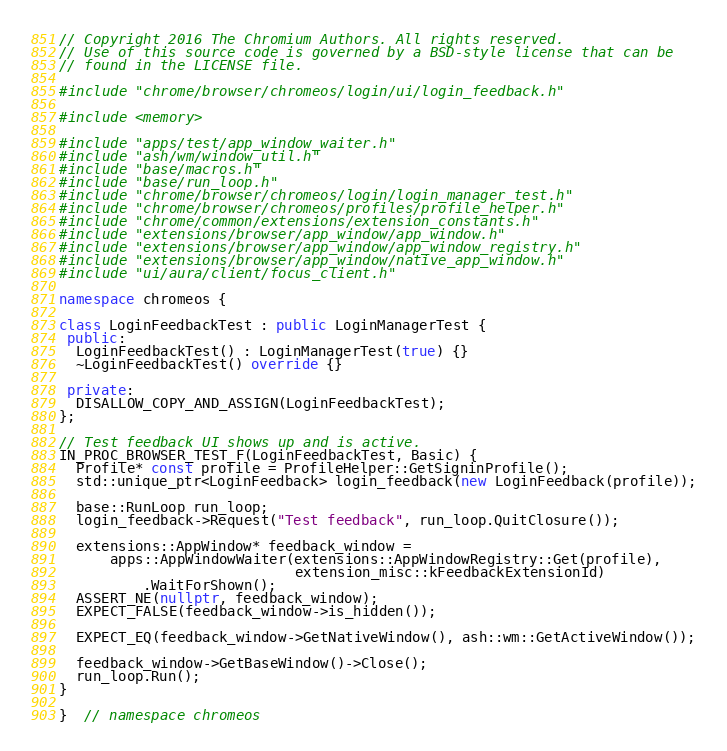<code> <loc_0><loc_0><loc_500><loc_500><_C++_>// Copyright 2016 The Chromium Authors. All rights reserved.
// Use of this source code is governed by a BSD-style license that can be
// found in the LICENSE file.

#include "chrome/browser/chromeos/login/ui/login_feedback.h"

#include <memory>

#include "apps/test/app_window_waiter.h"
#include "ash/wm/window_util.h"
#include "base/macros.h"
#include "base/run_loop.h"
#include "chrome/browser/chromeos/login/login_manager_test.h"
#include "chrome/browser/chromeos/profiles/profile_helper.h"
#include "chrome/common/extensions/extension_constants.h"
#include "extensions/browser/app_window/app_window.h"
#include "extensions/browser/app_window/app_window_registry.h"
#include "extensions/browser/app_window/native_app_window.h"
#include "ui/aura/client/focus_client.h"

namespace chromeos {

class LoginFeedbackTest : public LoginManagerTest {
 public:
  LoginFeedbackTest() : LoginManagerTest(true) {}
  ~LoginFeedbackTest() override {}

 private:
  DISALLOW_COPY_AND_ASSIGN(LoginFeedbackTest);
};

// Test feedback UI shows up and is active.
IN_PROC_BROWSER_TEST_F(LoginFeedbackTest, Basic) {
  Profile* const profile = ProfileHelper::GetSigninProfile();
  std::unique_ptr<LoginFeedback> login_feedback(new LoginFeedback(profile));

  base::RunLoop run_loop;
  login_feedback->Request("Test feedback", run_loop.QuitClosure());

  extensions::AppWindow* feedback_window =
      apps::AppWindowWaiter(extensions::AppWindowRegistry::Get(profile),
                            extension_misc::kFeedbackExtensionId)
          .WaitForShown();
  ASSERT_NE(nullptr, feedback_window);
  EXPECT_FALSE(feedback_window->is_hidden());

  EXPECT_EQ(feedback_window->GetNativeWindow(), ash::wm::GetActiveWindow());

  feedback_window->GetBaseWindow()->Close();
  run_loop.Run();
}

}  // namespace chromeos
</code> 